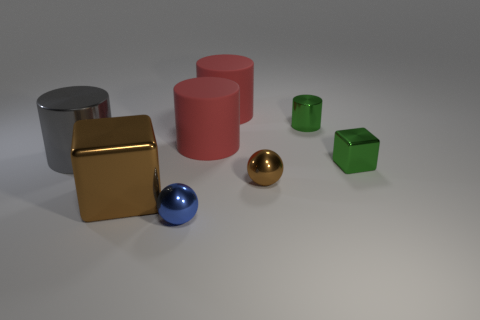Subtract all green cylinders. How many cylinders are left? 3 Add 2 tiny green cylinders. How many objects exist? 10 Subtract all brown spheres. How many spheres are left? 1 Subtract 2 cubes. How many cubes are left? 0 Add 5 large brown matte cylinders. How many large brown matte cylinders exist? 5 Subtract 1 green cylinders. How many objects are left? 7 Subtract all balls. How many objects are left? 6 Subtract all gray blocks. Subtract all red cylinders. How many blocks are left? 2 Subtract all red cubes. How many blue cylinders are left? 0 Subtract all matte things. Subtract all small blue balls. How many objects are left? 5 